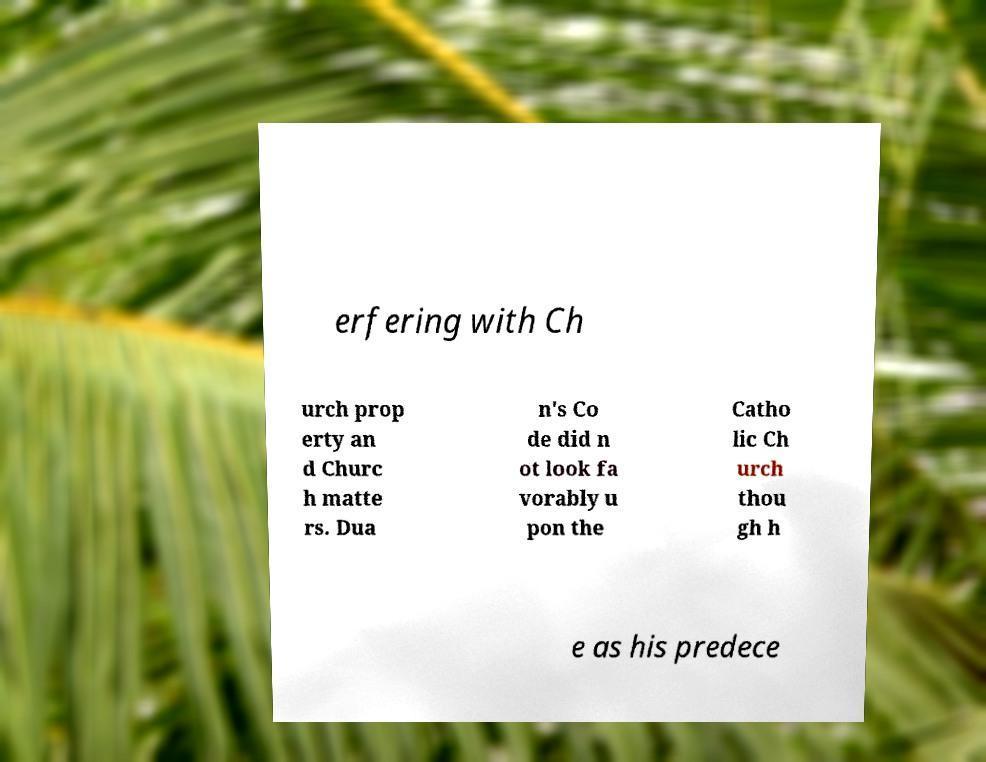What messages or text are displayed in this image? I need them in a readable, typed format. erfering with Ch urch prop erty an d Churc h matte rs. Dua n's Co de did n ot look fa vorably u pon the Catho lic Ch urch thou gh h e as his predece 